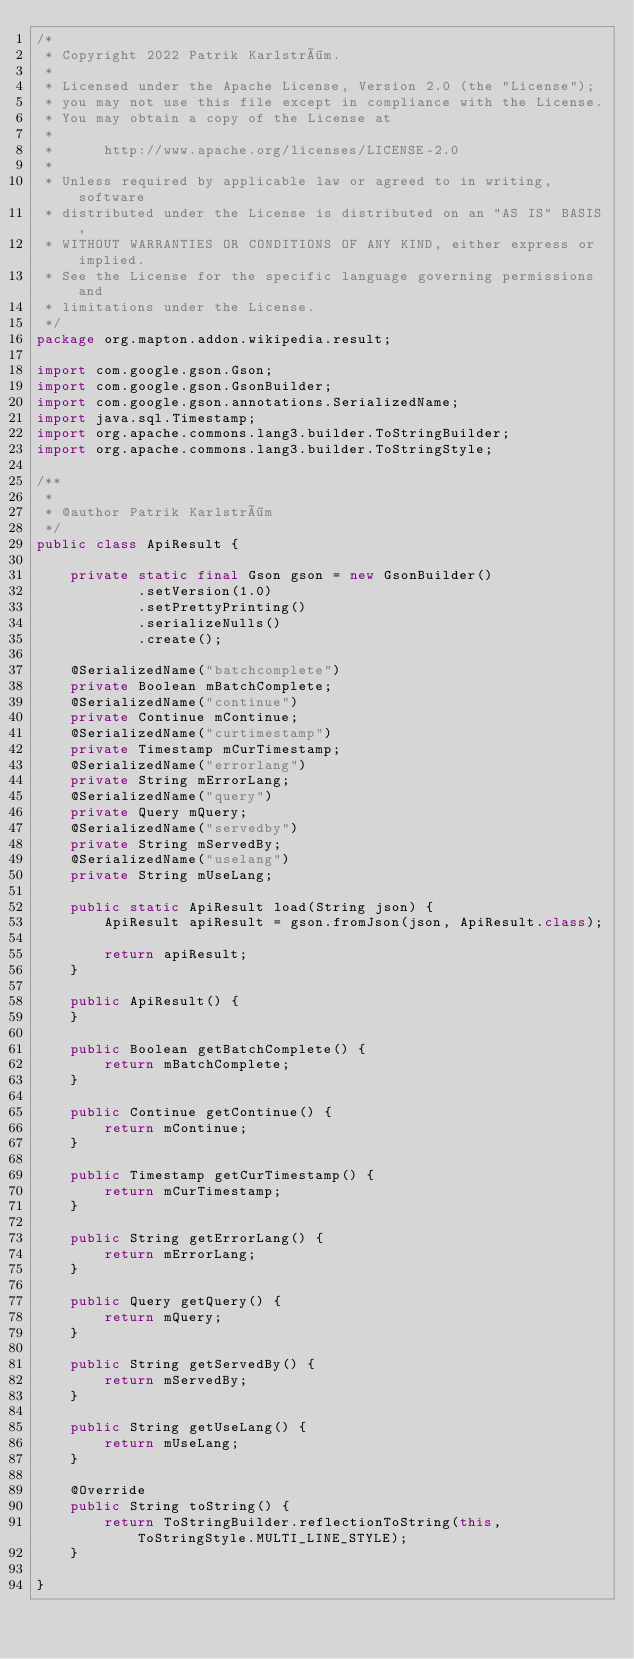Convert code to text. <code><loc_0><loc_0><loc_500><loc_500><_Java_>/*
 * Copyright 2022 Patrik Karlström.
 *
 * Licensed under the Apache License, Version 2.0 (the "License");
 * you may not use this file except in compliance with the License.
 * You may obtain a copy of the License at
 *
 *      http://www.apache.org/licenses/LICENSE-2.0
 *
 * Unless required by applicable law or agreed to in writing, software
 * distributed under the License is distributed on an "AS IS" BASIS,
 * WITHOUT WARRANTIES OR CONDITIONS OF ANY KIND, either express or implied.
 * See the License for the specific language governing permissions and
 * limitations under the License.
 */
package org.mapton.addon.wikipedia.result;

import com.google.gson.Gson;
import com.google.gson.GsonBuilder;
import com.google.gson.annotations.SerializedName;
import java.sql.Timestamp;
import org.apache.commons.lang3.builder.ToStringBuilder;
import org.apache.commons.lang3.builder.ToStringStyle;

/**
 *
 * @author Patrik Karlström
 */
public class ApiResult {

    private static final Gson gson = new GsonBuilder()
            .setVersion(1.0)
            .setPrettyPrinting()
            .serializeNulls()
            .create();

    @SerializedName("batchcomplete")
    private Boolean mBatchComplete;
    @SerializedName("continue")
    private Continue mContinue;
    @SerializedName("curtimestamp")
    private Timestamp mCurTimestamp;
    @SerializedName("errorlang")
    private String mErrorLang;
    @SerializedName("query")
    private Query mQuery;
    @SerializedName("servedby")
    private String mServedBy;
    @SerializedName("uselang")
    private String mUseLang;

    public static ApiResult load(String json) {
        ApiResult apiResult = gson.fromJson(json, ApiResult.class);

        return apiResult;
    }

    public ApiResult() {
    }

    public Boolean getBatchComplete() {
        return mBatchComplete;
    }

    public Continue getContinue() {
        return mContinue;
    }

    public Timestamp getCurTimestamp() {
        return mCurTimestamp;
    }

    public String getErrorLang() {
        return mErrorLang;
    }

    public Query getQuery() {
        return mQuery;
    }

    public String getServedBy() {
        return mServedBy;
    }

    public String getUseLang() {
        return mUseLang;
    }

    @Override
    public String toString() {
        return ToStringBuilder.reflectionToString(this, ToStringStyle.MULTI_LINE_STYLE);
    }

}
</code> 